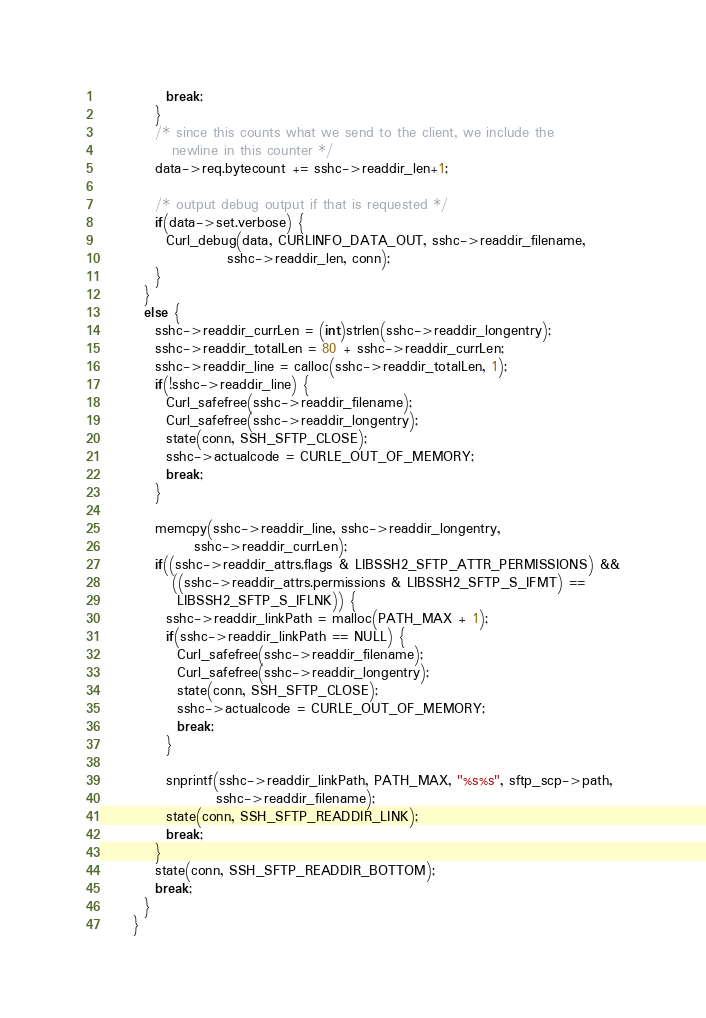Convert code to text. <code><loc_0><loc_0><loc_500><loc_500><_C_>            break;
          }
          /* since this counts what we send to the client, we include the
             newline in this counter */
          data->req.bytecount += sshc->readdir_len+1;

          /* output debug output if that is requested */
          if(data->set.verbose) {
            Curl_debug(data, CURLINFO_DATA_OUT, sshc->readdir_filename,
                       sshc->readdir_len, conn);
          }
        }
        else {
          sshc->readdir_currLen = (int)strlen(sshc->readdir_longentry);
          sshc->readdir_totalLen = 80 + sshc->readdir_currLen;
          sshc->readdir_line = calloc(sshc->readdir_totalLen, 1);
          if(!sshc->readdir_line) {
            Curl_safefree(sshc->readdir_filename);
            Curl_safefree(sshc->readdir_longentry);
            state(conn, SSH_SFTP_CLOSE);
            sshc->actualcode = CURLE_OUT_OF_MEMORY;
            break;
          }

          memcpy(sshc->readdir_line, sshc->readdir_longentry,
                 sshc->readdir_currLen);
          if((sshc->readdir_attrs.flags & LIBSSH2_SFTP_ATTR_PERMISSIONS) &&
             ((sshc->readdir_attrs.permissions & LIBSSH2_SFTP_S_IFMT) ==
              LIBSSH2_SFTP_S_IFLNK)) {
            sshc->readdir_linkPath = malloc(PATH_MAX + 1);
            if(sshc->readdir_linkPath == NULL) {
              Curl_safefree(sshc->readdir_filename);
              Curl_safefree(sshc->readdir_longentry);
              state(conn, SSH_SFTP_CLOSE);
              sshc->actualcode = CURLE_OUT_OF_MEMORY;
              break;
            }

            snprintf(sshc->readdir_linkPath, PATH_MAX, "%s%s", sftp_scp->path,
                     sshc->readdir_filename);
            state(conn, SSH_SFTP_READDIR_LINK);
            break;
          }
          state(conn, SSH_SFTP_READDIR_BOTTOM);
          break;
        }
      }</code> 